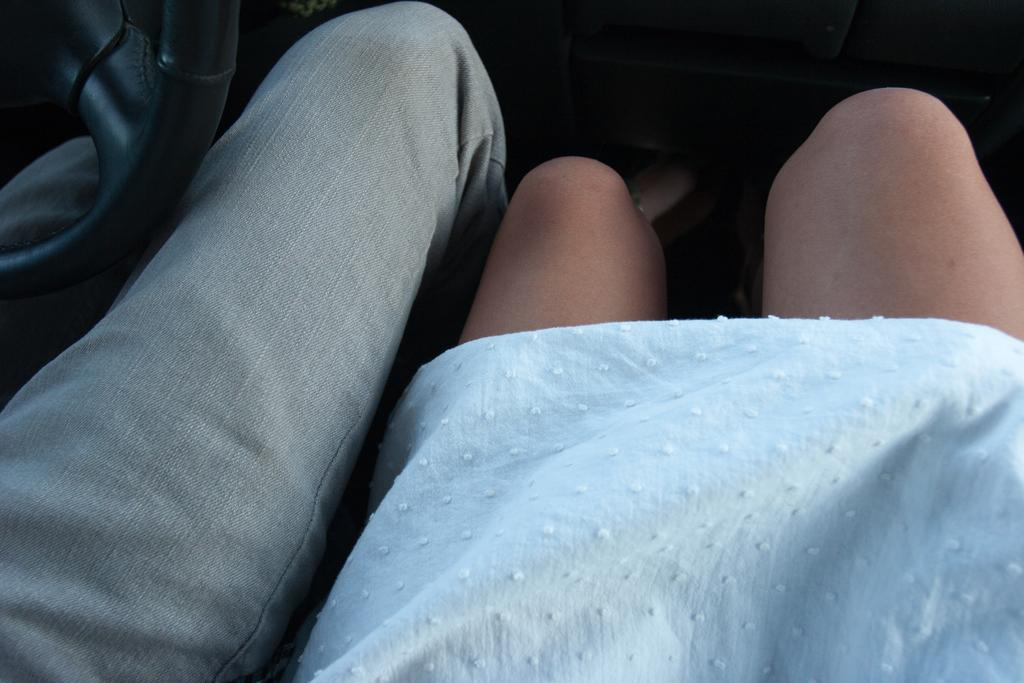What can be seen in the image that indicates the presence of two persons? There are legs of two persons visible in the image. What object is located on the left side of the image? There is a steering on the left side of the image. What type of milk is being poured into the bells in the image? There is no milk or bells present in the image. What type of street is visible in the image? There is no street visible in the image. 